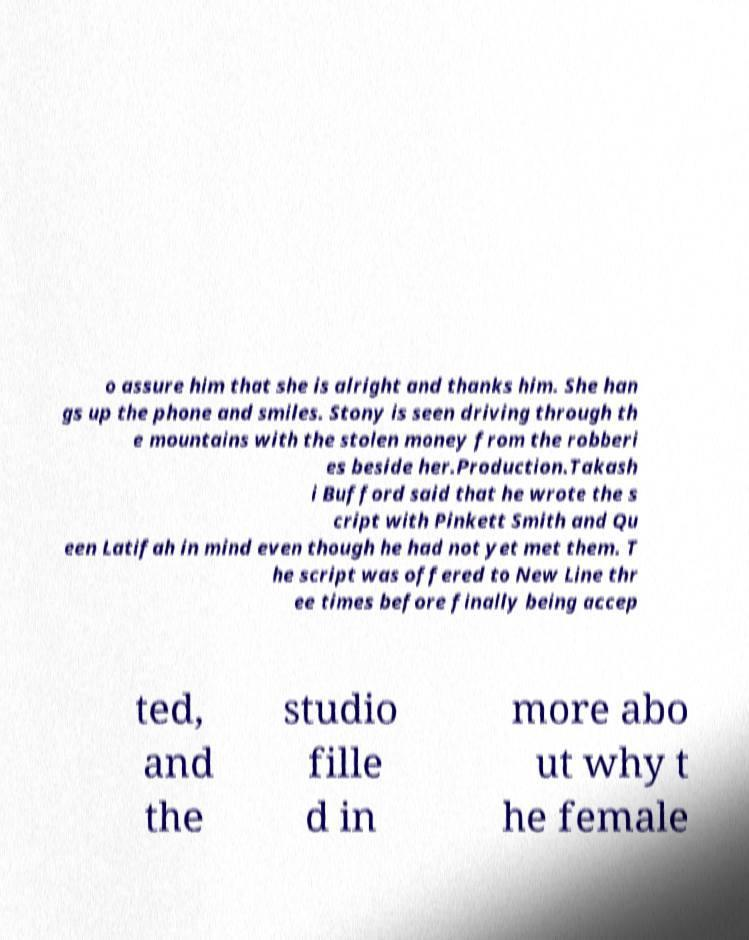Please read and relay the text visible in this image. What does it say? o assure him that she is alright and thanks him. She han gs up the phone and smiles. Stony is seen driving through th e mountains with the stolen money from the robberi es beside her.Production.Takash i Bufford said that he wrote the s cript with Pinkett Smith and Qu een Latifah in mind even though he had not yet met them. T he script was offered to New Line thr ee times before finally being accep ted, and the studio fille d in more abo ut why t he female 